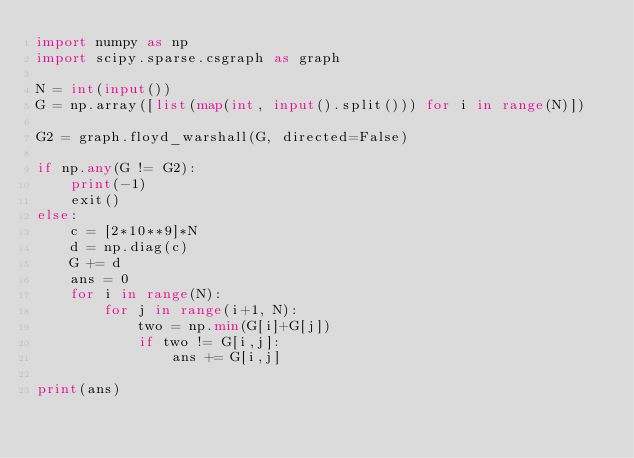<code> <loc_0><loc_0><loc_500><loc_500><_Python_>import numpy as np
import scipy.sparse.csgraph as graph

N = int(input())
G = np.array([list(map(int, input().split())) for i in range(N)])

G2 = graph.floyd_warshall(G, directed=False)

if np.any(G != G2):
    print(-1)
    exit()
else:
    c = [2*10**9]*N
    d = np.diag(c)
    G += d
    ans = 0
    for i in range(N):
        for j in range(i+1, N):
            two = np.min(G[i]+G[j])
            if two != G[i,j]:
                ans += G[i,j]

print(ans)
</code> 